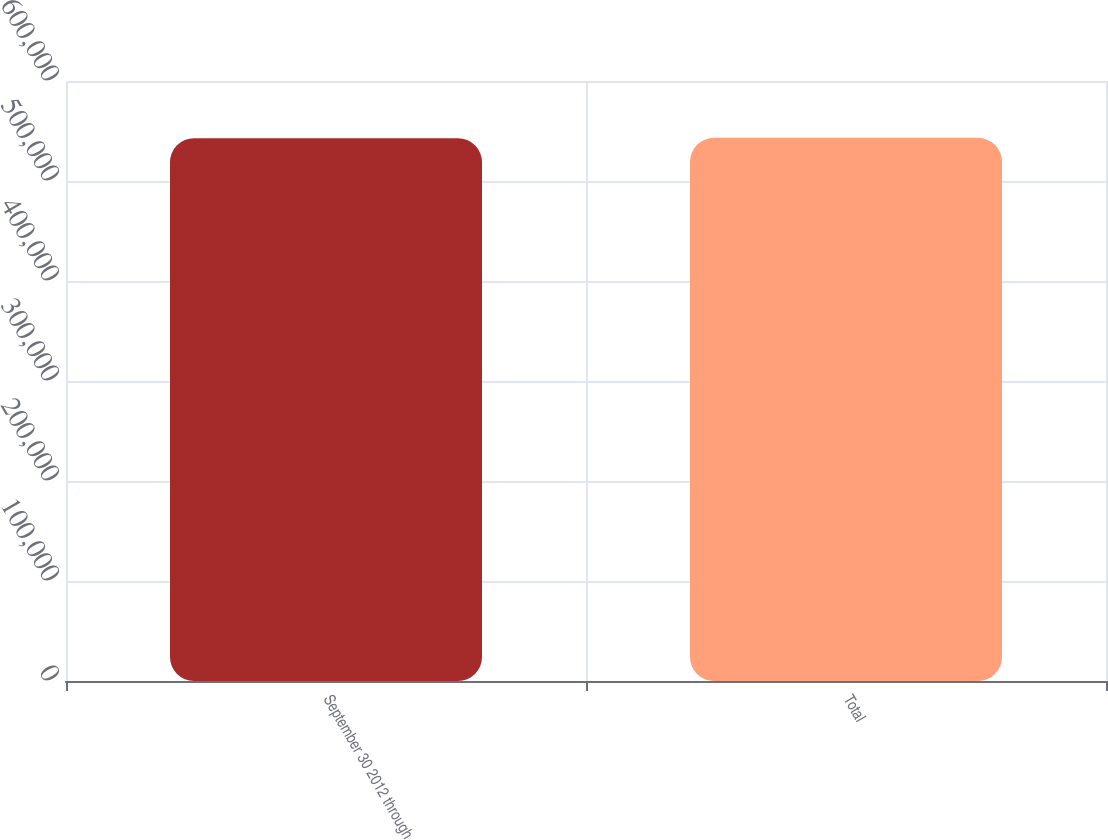<chart> <loc_0><loc_0><loc_500><loc_500><bar_chart><fcel>September 30 2012 through<fcel>Total<nl><fcel>542840<fcel>543167<nl></chart> 